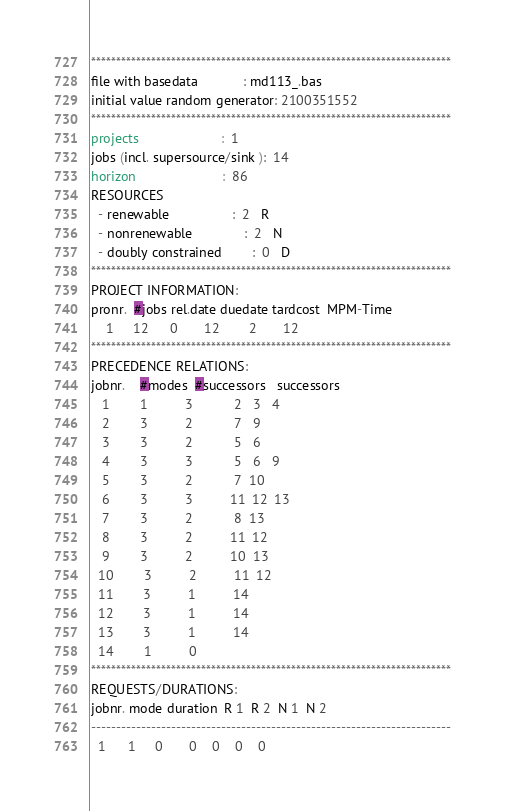<code> <loc_0><loc_0><loc_500><loc_500><_ObjectiveC_>************************************************************************
file with basedata            : md113_.bas
initial value random generator: 2100351552
************************************************************************
projects                      :  1
jobs (incl. supersource/sink ):  14
horizon                       :  86
RESOURCES
  - renewable                 :  2   R
  - nonrenewable              :  2   N
  - doubly constrained        :  0   D
************************************************************************
PROJECT INFORMATION:
pronr.  #jobs rel.date duedate tardcost  MPM-Time
    1     12      0       12        2       12
************************************************************************
PRECEDENCE RELATIONS:
jobnr.    #modes  #successors   successors
   1        1          3           2   3   4
   2        3          2           7   9
   3        3          2           5   6
   4        3          3           5   6   9
   5        3          2           7  10
   6        3          3          11  12  13
   7        3          2           8  13
   8        3          2          11  12
   9        3          2          10  13
  10        3          2          11  12
  11        3          1          14
  12        3          1          14
  13        3          1          14
  14        1          0        
************************************************************************
REQUESTS/DURATIONS:
jobnr. mode duration  R 1  R 2  N 1  N 2
------------------------------------------------------------------------
  1      1     0       0    0    0    0</code> 